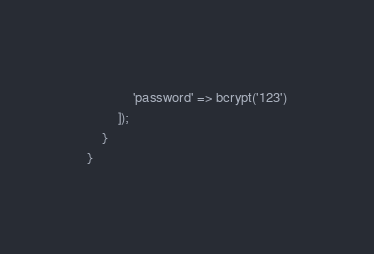<code> <loc_0><loc_0><loc_500><loc_500><_PHP_>            'password' => bcrypt('123')
        ]);
    }
}
</code> 